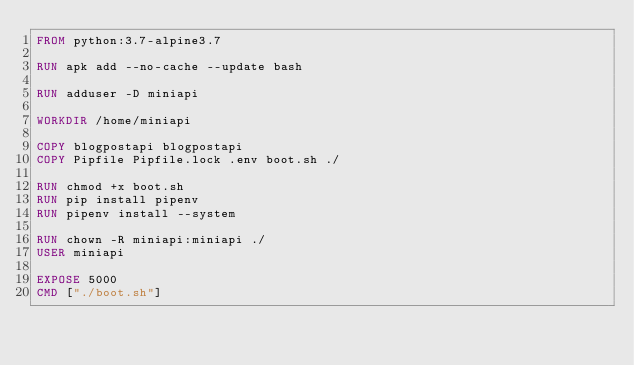Convert code to text. <code><loc_0><loc_0><loc_500><loc_500><_Dockerfile_>FROM python:3.7-alpine3.7

RUN apk add --no-cache --update bash

RUN adduser -D miniapi

WORKDIR /home/miniapi

COPY blogpostapi blogpostapi
COPY Pipfile Pipfile.lock .env boot.sh ./

RUN chmod +x boot.sh
RUN pip install pipenv
RUN pipenv install --system

RUN chown -R miniapi:miniapi ./
USER miniapi

EXPOSE 5000
CMD ["./boot.sh"]
</code> 